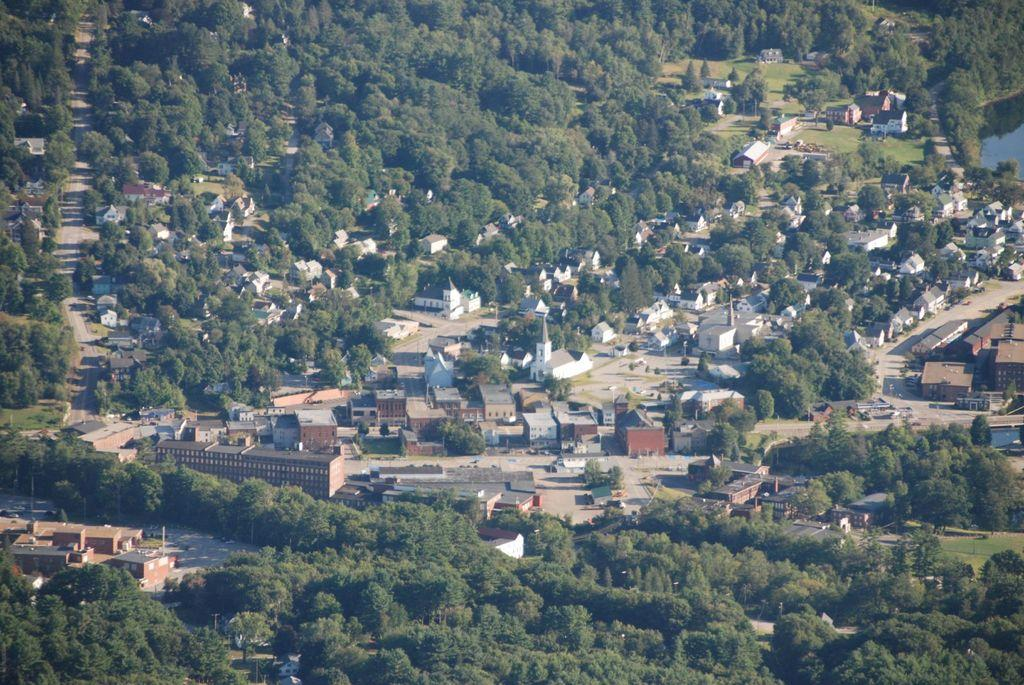What perspective is the image taken from? The image is taken from a top view. What type of natural elements can be seen in the image? There are many trees in the image. What type of man-made structures are present in the image? There are buildings and houses in the image. What type of transportation infrastructure is visible in the image? Roads are visible in the image. What type of geographical feature is visible in the image? Water is visible in the image. What type of drink is being served at the house in the image? There is no information about drinks being served in the image; it only shows trees, buildings, houses, roads, and water. What type of tool is being used by the mother in the image? There is no mother or tool present in the image. 